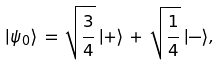<formula> <loc_0><loc_0><loc_500><loc_500>| \psi _ { 0 } \rangle \, = \, \sqrt { \frac { 3 } { 4 } } \, | + \rangle \, + \, \sqrt { \frac { 1 } { 4 } } \, | - \rangle ,</formula> 